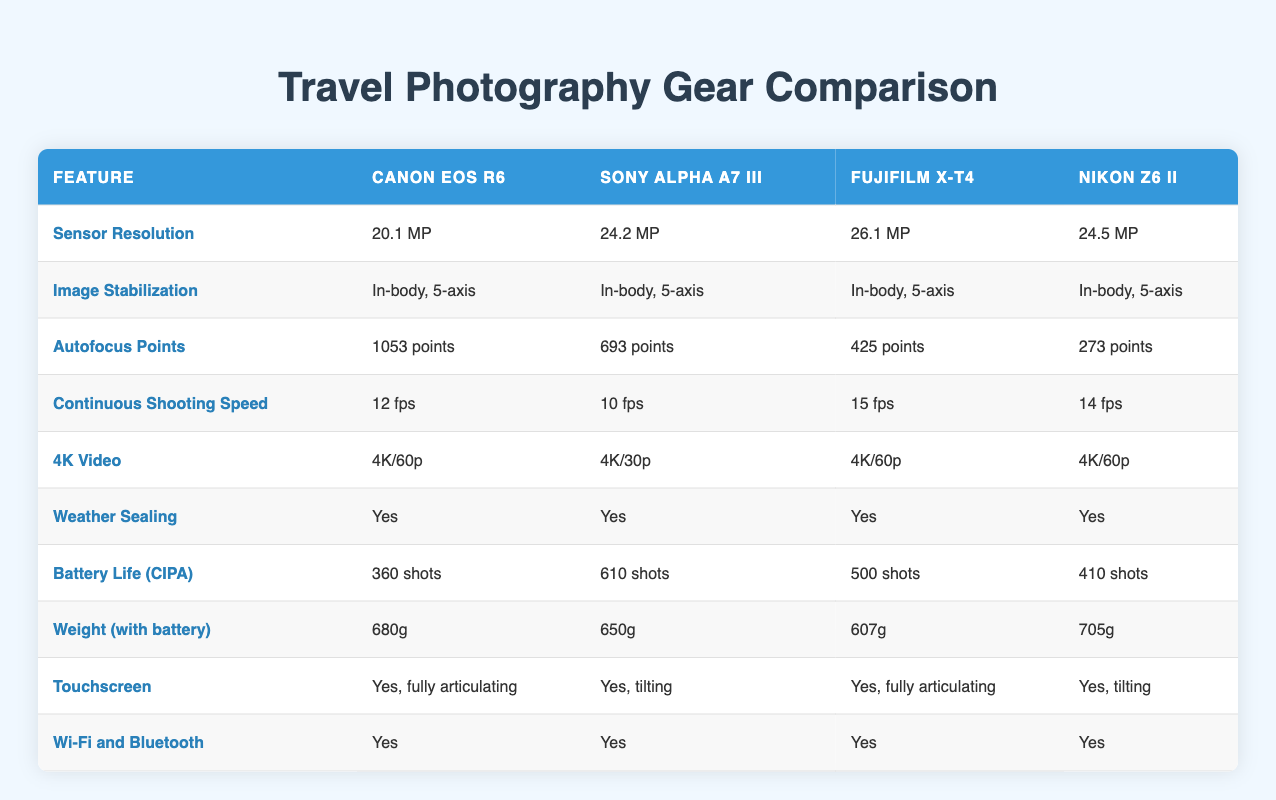What is the sensor resolution of Fujifilm X-T4? The table indicates the sensor resolution for Fujifilm X-T4 is 26.1 MP. You can find this information under the "Fujifilm X-T4" column in the "Sensor Resolution" row.
Answer: 26.1 MP Which camera has the highest continuous shooting speed? Looking at the "Continuous Shooting Speed" row, the table shows that Fujifilm X-T4 has a shooting speed of 15 fps, which is the highest compared to the other cameras listed.
Answer: Fujifilm X-T4 How many more autofocus points does Canon EOS R6 have than Nikon Z6 II? The Canon EOS R6 has 1053 autofocus points, while the Nikon Z6 II has 273. The difference is calculated as 1053 - 273 = 780 points.
Answer: 780 points Is there any camera that has a battery life of more than 500 shots? Referring to the "Battery Life (CIPA)" row, the Sony Alpha A7 III has a battery life of 610 shots, which is greater than 500.
Answer: Yes What is the average weight of the cameras listed in the table? The weights for the cameras are 680g (Canon EOS R6), 650g (Sony Alpha A7 III), 607g (Fujifilm X-T4), and 705g (Nikon Z6 II). First, sum the weights: 680 + 650 + 607 + 705 = 2642g. Then, divide by the number of cameras (4): 2642g / 4 = 660.5g.
Answer: 660.5g Does every camera have weather sealing? The table indicates that all cameras (Canon EOS R6, Sony Alpha A7 III, Fujifilm X-T4, and Nikon Z6 II) have weather sealing, as every entry in the "Weather Sealing" row shows "Yes."
Answer: Yes What is the difference in sensor resolution between the highest and lowest in the table? The highest sensor resolution is 26.1 MP for Fujifilm X-T4 and the lowest is 20.1 MP for Canon EOS R6. The difference is calculated as 26.1 MP - 20.1 MP = 6.0 MP.
Answer: 6.0 MP Which camera has the least battery life among those listed? Analyzing the "Battery Life (CIPA)" row, the Canon EOS R6 has the least battery life with 360 shots compared to others.
Answer: Canon EOS R6 